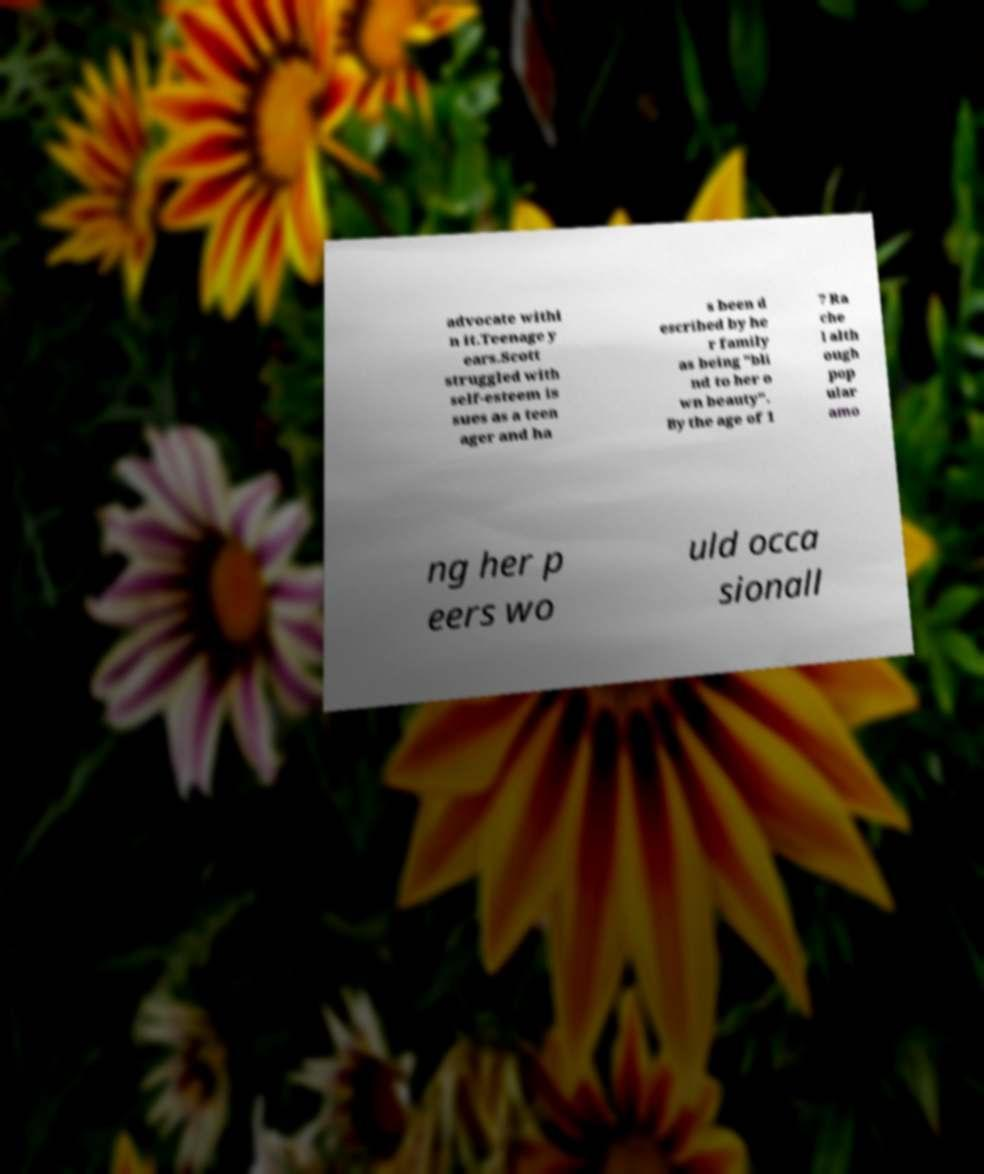What messages or text are displayed in this image? I need them in a readable, typed format. advocate withi n it.Teenage y ears.Scott struggled with self-esteem is sues as a teen ager and ha s been d escribed by he r family as being "bli nd to her o wn beauty". By the age of 1 7 Ra che l alth ough pop ular amo ng her p eers wo uld occa sionall 